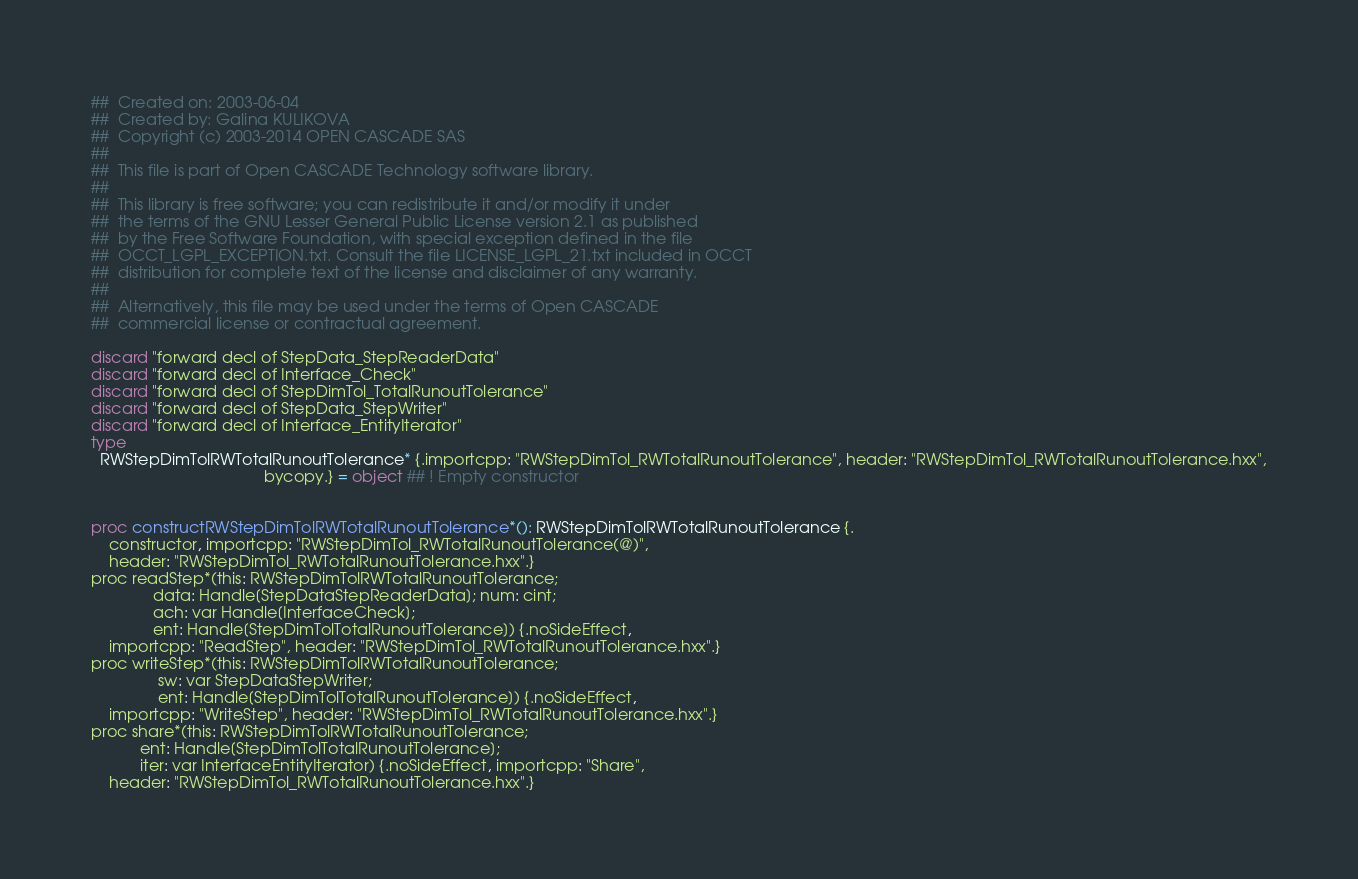<code> <loc_0><loc_0><loc_500><loc_500><_Nim_>##  Created on: 2003-06-04
##  Created by: Galina KULIKOVA
##  Copyright (c) 2003-2014 OPEN CASCADE SAS
##
##  This file is part of Open CASCADE Technology software library.
##
##  This library is free software; you can redistribute it and/or modify it under
##  the terms of the GNU Lesser General Public License version 2.1 as published
##  by the Free Software Foundation, with special exception defined in the file
##  OCCT_LGPL_EXCEPTION.txt. Consult the file LICENSE_LGPL_21.txt included in OCCT
##  distribution for complete text of the license and disclaimer of any warranty.
##
##  Alternatively, this file may be used under the terms of Open CASCADE
##  commercial license or contractual agreement.

discard "forward decl of StepData_StepReaderData"
discard "forward decl of Interface_Check"
discard "forward decl of StepDimTol_TotalRunoutTolerance"
discard "forward decl of StepData_StepWriter"
discard "forward decl of Interface_EntityIterator"
type
  RWStepDimTolRWTotalRunoutTolerance* {.importcpp: "RWStepDimTol_RWTotalRunoutTolerance", header: "RWStepDimTol_RWTotalRunoutTolerance.hxx",
                                       bycopy.} = object ## ! Empty constructor


proc constructRWStepDimTolRWTotalRunoutTolerance*(): RWStepDimTolRWTotalRunoutTolerance {.
    constructor, importcpp: "RWStepDimTol_RWTotalRunoutTolerance(@)",
    header: "RWStepDimTol_RWTotalRunoutTolerance.hxx".}
proc readStep*(this: RWStepDimTolRWTotalRunoutTolerance;
              data: Handle[StepDataStepReaderData]; num: cint;
              ach: var Handle[InterfaceCheck];
              ent: Handle[StepDimTolTotalRunoutTolerance]) {.noSideEffect,
    importcpp: "ReadStep", header: "RWStepDimTol_RWTotalRunoutTolerance.hxx".}
proc writeStep*(this: RWStepDimTolRWTotalRunoutTolerance;
               sw: var StepDataStepWriter;
               ent: Handle[StepDimTolTotalRunoutTolerance]) {.noSideEffect,
    importcpp: "WriteStep", header: "RWStepDimTol_RWTotalRunoutTolerance.hxx".}
proc share*(this: RWStepDimTolRWTotalRunoutTolerance;
           ent: Handle[StepDimTolTotalRunoutTolerance];
           iter: var InterfaceEntityIterator) {.noSideEffect, importcpp: "Share",
    header: "RWStepDimTol_RWTotalRunoutTolerance.hxx".}

























</code> 